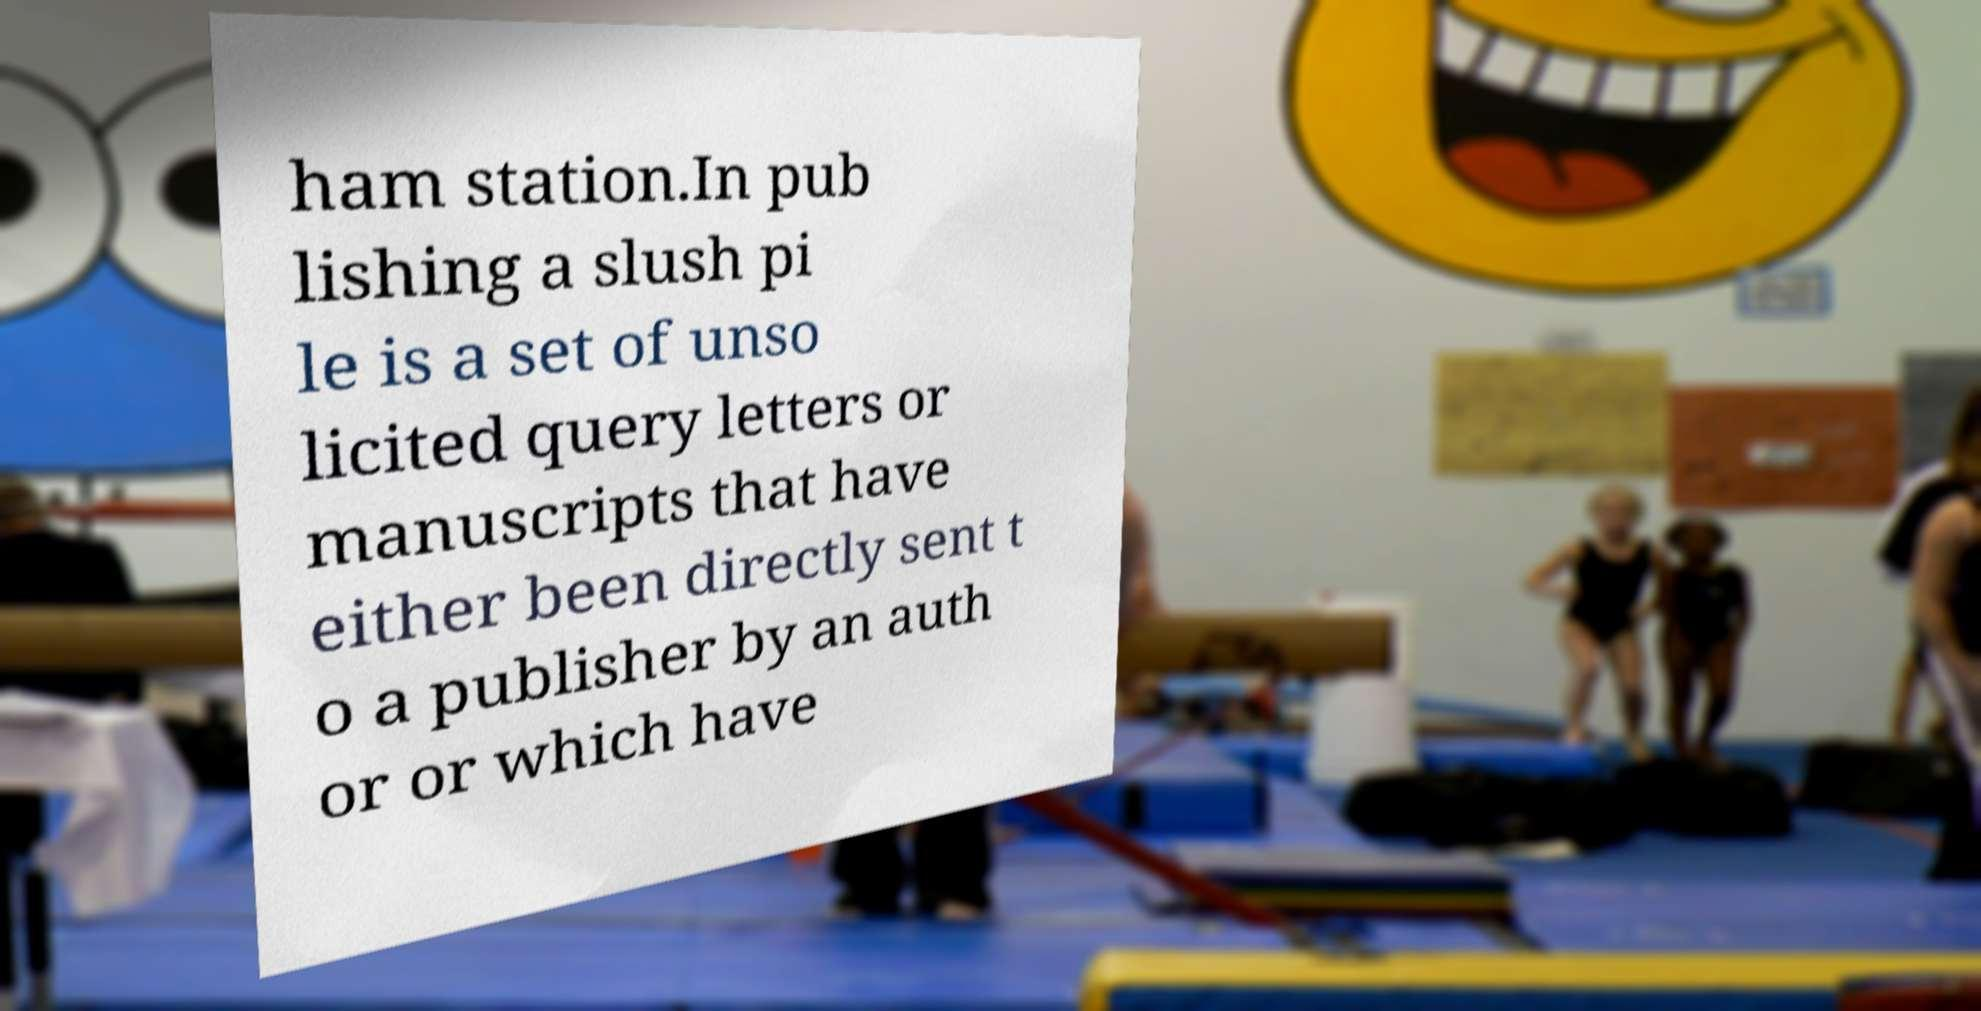Please identify and transcribe the text found in this image. ham station.In pub lishing a slush pi le is a set of unso licited query letters or manuscripts that have either been directly sent t o a publisher by an auth or or which have 